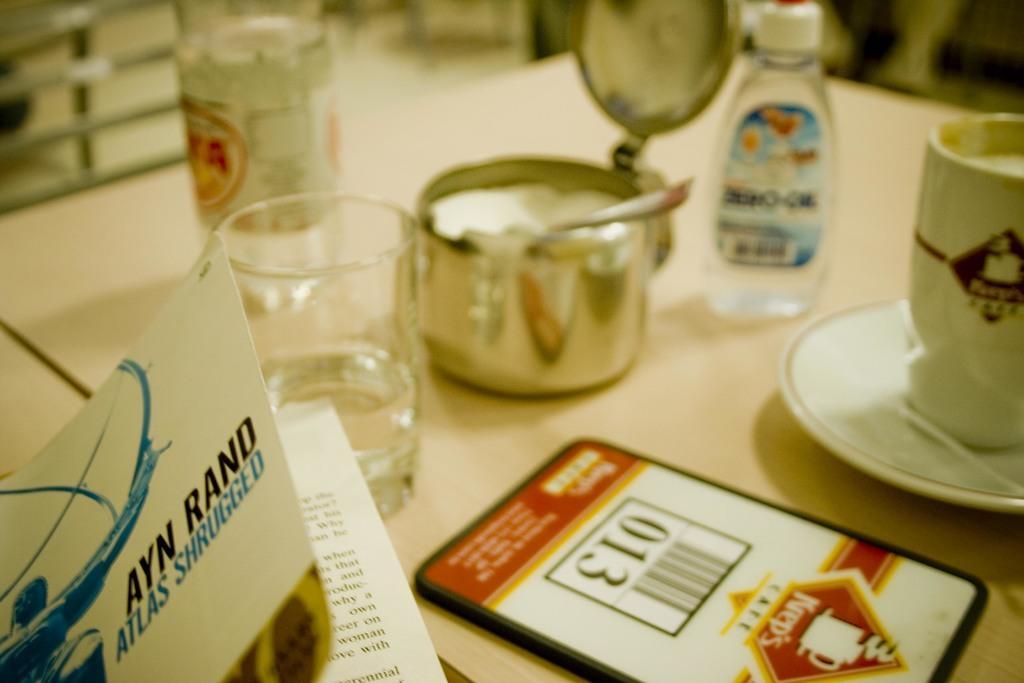Could you give a brief overview of what you see in this image? In this picture I can see couple of bottles, a glass and a cup with a saucer and I can see a box, a spoon and a ID card on the table. I can see a book at the bottom left corner of the picture. 